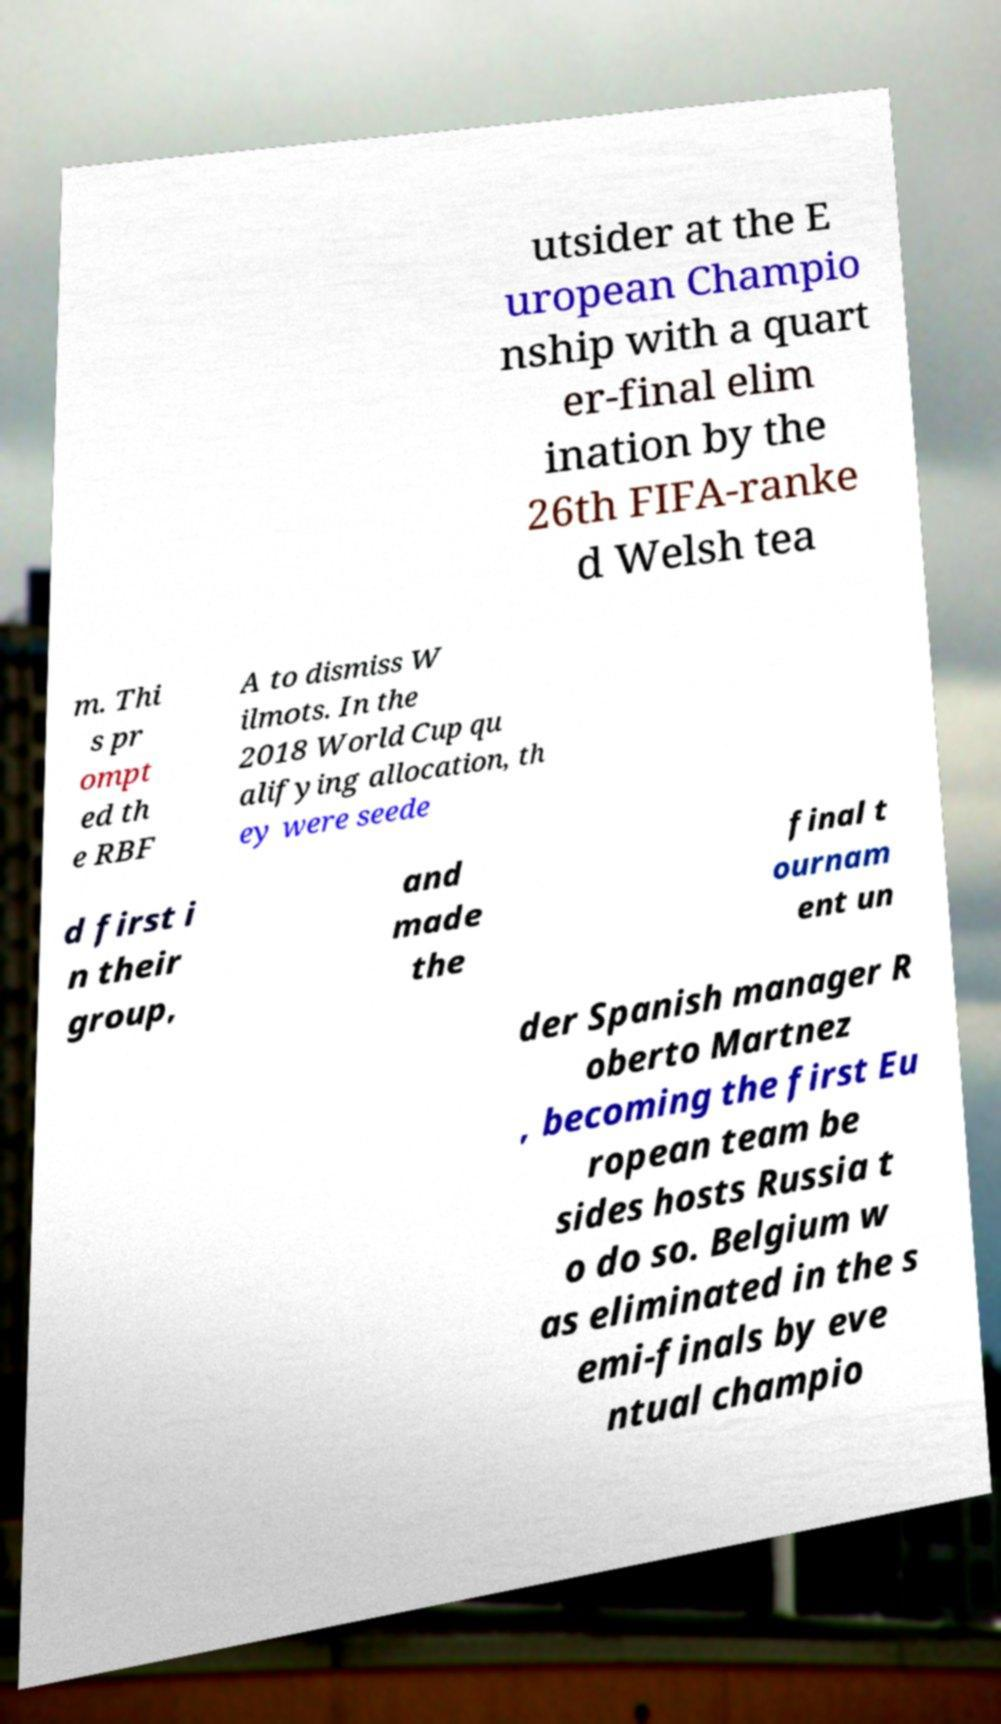Could you extract and type out the text from this image? utsider at the E uropean Champio nship with a quart er-final elim ination by the 26th FIFA-ranke d Welsh tea m. Thi s pr ompt ed th e RBF A to dismiss W ilmots. In the 2018 World Cup qu alifying allocation, th ey were seede d first i n their group, and made the final t ournam ent un der Spanish manager R oberto Martnez , becoming the first Eu ropean team be sides hosts Russia t o do so. Belgium w as eliminated in the s emi-finals by eve ntual champio 